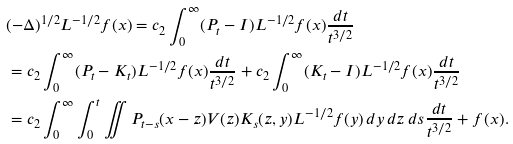Convert formula to latex. <formula><loc_0><loc_0><loc_500><loc_500>& ( - \Delta ) ^ { 1 \slash 2 } L ^ { - 1 \slash 2 } f ( x ) = c _ { 2 } \int _ { 0 } ^ { \infty } ( P _ { t } - I ) L ^ { - 1 \slash 2 } f ( x ) \frac { d t } { t ^ { 3 \slash 2 } } \\ & = c _ { 2 } \int _ { 0 } ^ { \infty } ( P _ { t } - K _ { t } ) L ^ { - 1 \slash 2 } f ( x ) \frac { d t } { t ^ { 3 \slash 2 } } + c _ { 2 } \int _ { 0 } ^ { \infty } ( K _ { t } - I ) L ^ { - 1 \slash 2 } f ( x ) \frac { d t } { t ^ { 3 \slash 2 } } \\ & = c _ { 2 } \int _ { 0 } ^ { \infty } \int _ { 0 } ^ { t } \iint P _ { t - s } ( x - z ) V ( z ) K _ { s } ( z , y ) L ^ { - 1 \slash 2 } f ( y ) \, d y \, d z \, d s \frac { d t } { t ^ { 3 \slash 2 } } + f ( x ) . \\</formula> 